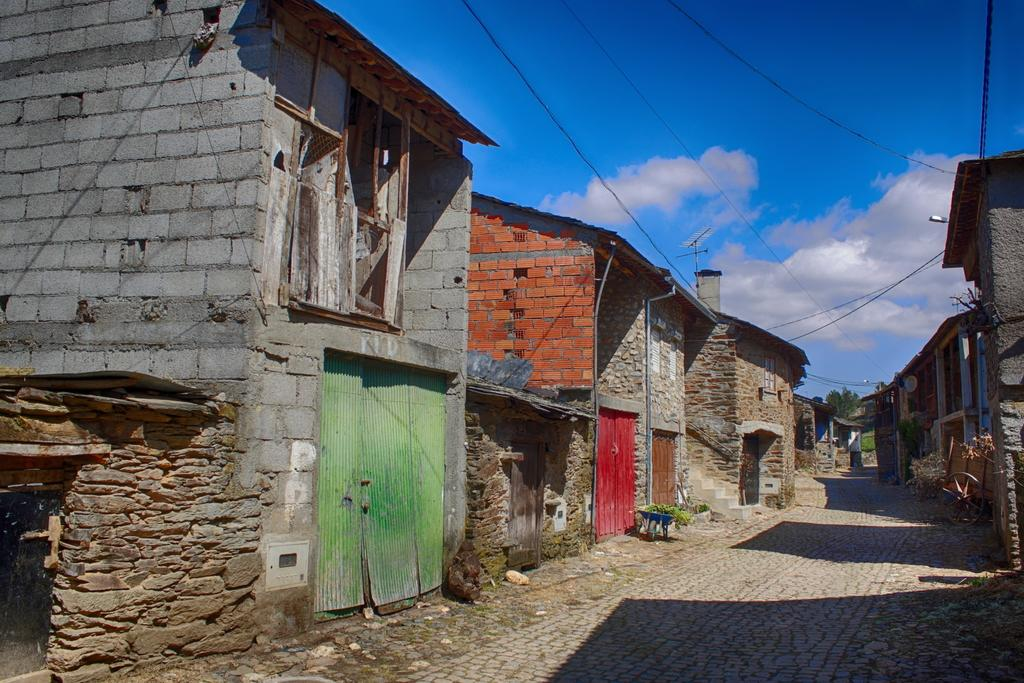What type of structures can be seen in the image? There are houses in the image. What object resembles a circular shape in the image? There is an object that looks like a wheel in the image. What vertical structure is present in the image? There is an electrical pole in the image. What type of vegetation is visible in the image? There are trees in the image. What can be seen in the distance in the image? The sky is visible in the background of the image. How many pizzas are being served in the scene? There is no scene involving pizzas in the image; it features houses, a wheel-like object, an electrical pole, trees, and a visible sky. What level of detail can be observed in the image? The level of detail in the image cannot be determined from the provided facts, as it is subjective and depends on the quality of the image and the viewer's perception. 